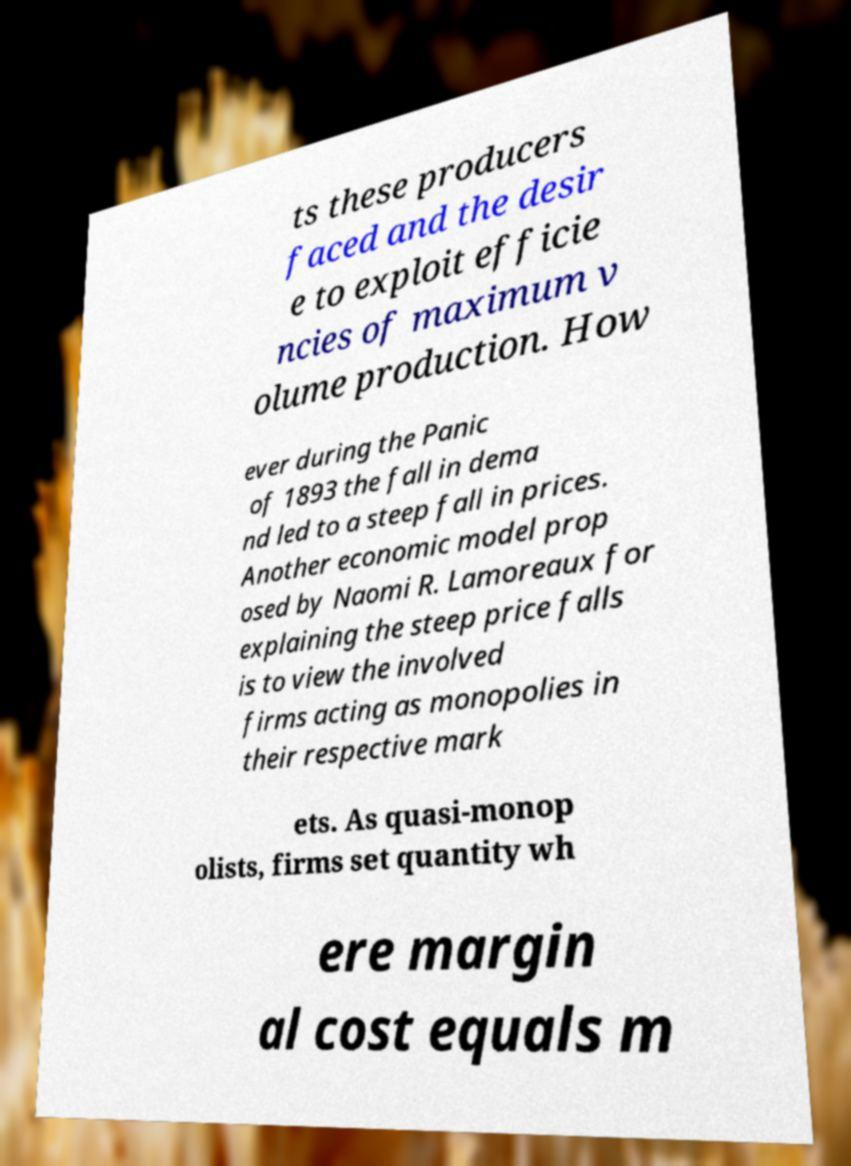Please read and relay the text visible in this image. What does it say? ts these producers faced and the desir e to exploit efficie ncies of maximum v olume production. How ever during the Panic of 1893 the fall in dema nd led to a steep fall in prices. Another economic model prop osed by Naomi R. Lamoreaux for explaining the steep price falls is to view the involved firms acting as monopolies in their respective mark ets. As quasi-monop olists, firms set quantity wh ere margin al cost equals m 